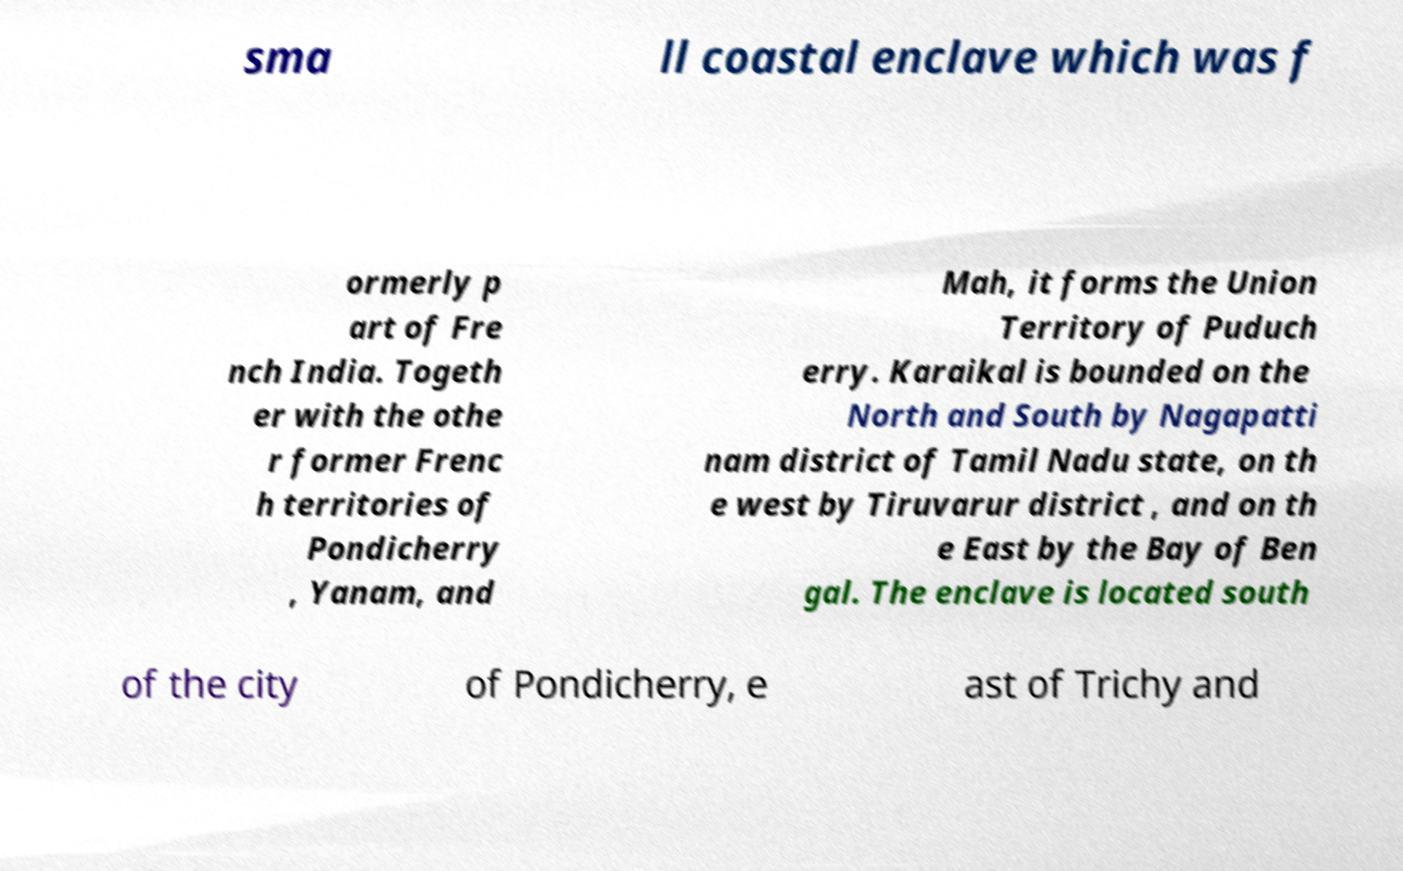For documentation purposes, I need the text within this image transcribed. Could you provide that? sma ll coastal enclave which was f ormerly p art of Fre nch India. Togeth er with the othe r former Frenc h territories of Pondicherry , Yanam, and Mah, it forms the Union Territory of Puduch erry. Karaikal is bounded on the North and South by Nagapatti nam district of Tamil Nadu state, on th e west by Tiruvarur district , and on th e East by the Bay of Ben gal. The enclave is located south of the city of Pondicherry, e ast of Trichy and 